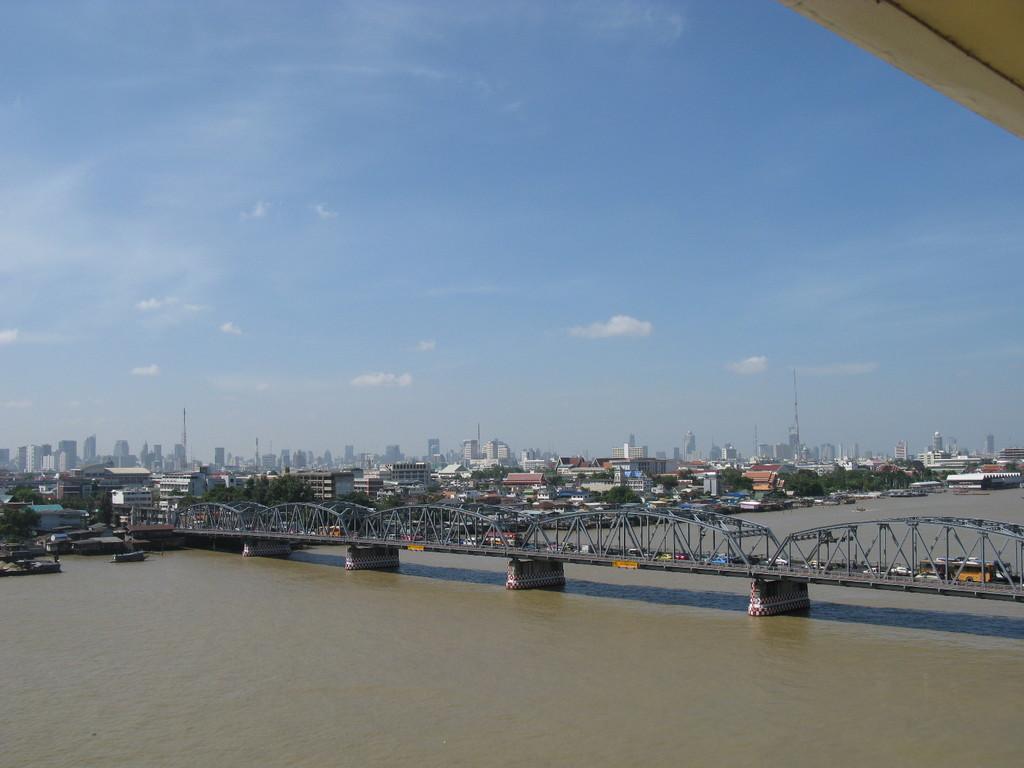In one or two sentences, can you explain what this image depicts? In this image, I can see the vehicles on the bridge, which is across the river. In the background, there are buildings, trees and the sky. 